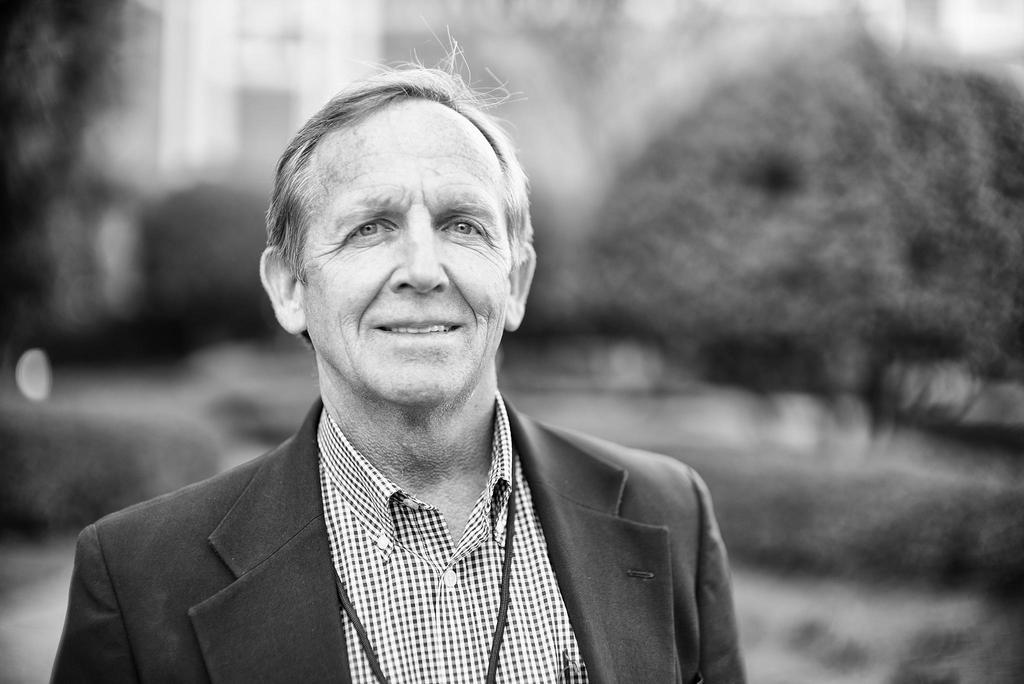What is the color scheme of the image? The image is black and white. What can be seen in the image besides the color scheme? There is a person standing in the image. What is the person wearing on their upper body? The person is wearing a shirt and a coat. How much butter is visible on the person's coat in the image? There is no butter present in the image, so it cannot be determined how much butter might be visible on the person's coat. 